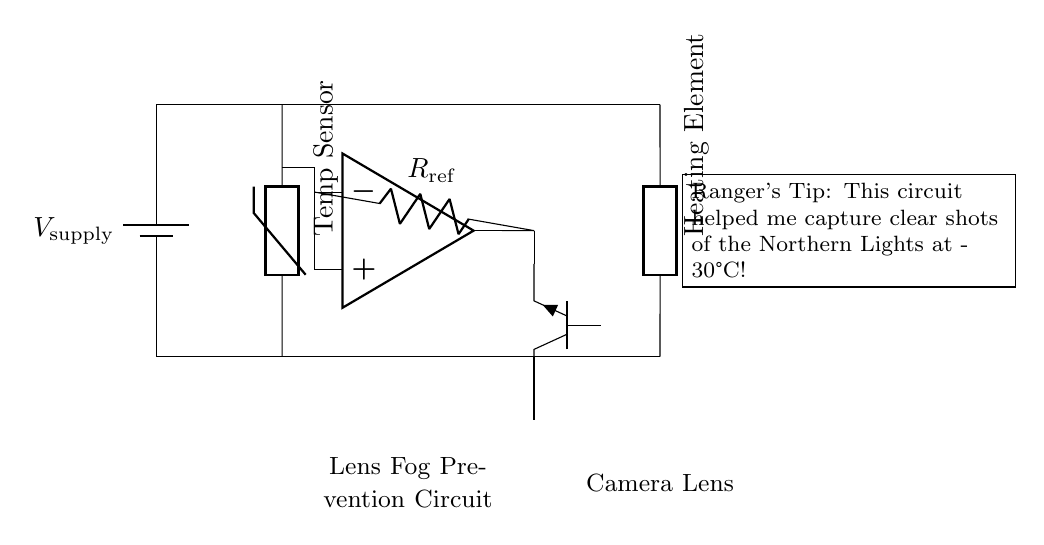What type of sensor is used in this circuit? The circuit diagram indicates that a thermistor is used as the temperature sensor, which is essential for detecting temperature variations.
Answer: Thermistor What component controls the heating element? The heating element is controlled by the transistor, specifically an NPN type, which activates based on the signal from the comparator.
Answer: Transistor What is the role of the comparator in this circuit? The comparator's role is to compare the voltage from the thermistor with a reference voltage from the resistor, determining whether to turn the heating element on or off based on temperature.
Answer: Control How many power supply terminals are shown in the circuit? The diagram illustrates one power supply terminal, which connects to both the upper part of the circuit and the heater, providing the necessary voltage.
Answer: One At what temperature is this circuit particularly useful for photography? The ranger's tip mentions that this circuit was effective in temperatures as low as minus thirty degrees Celsius, helping prevent lens fogging.
Answer: Minus thirty degrees Celsius What type of heating element is shown in the circuit? The diagram depicts a generic heating element, designed to warm the camera lens to prevent fogging that occurs in cold climates.
Answer: Generic What is the labeled reference resistor in the circuit? The circuit has a resistor labeled as R reference, providing a steady reference voltage for the comparator to compare with the thermistor's output.
Answer: R reference 